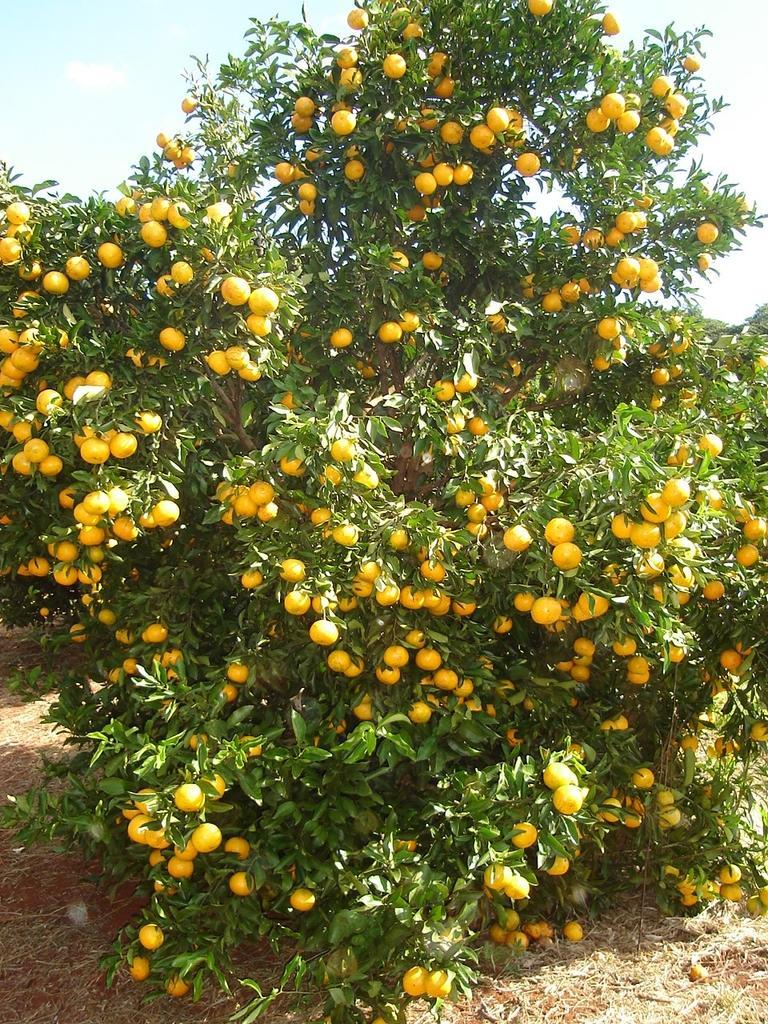In one or two sentences, can you explain what this image depicts? In this image we can see a tree with fruits. In the background of the image there is the sky. At the bottom of the image there is the grass and ground. 